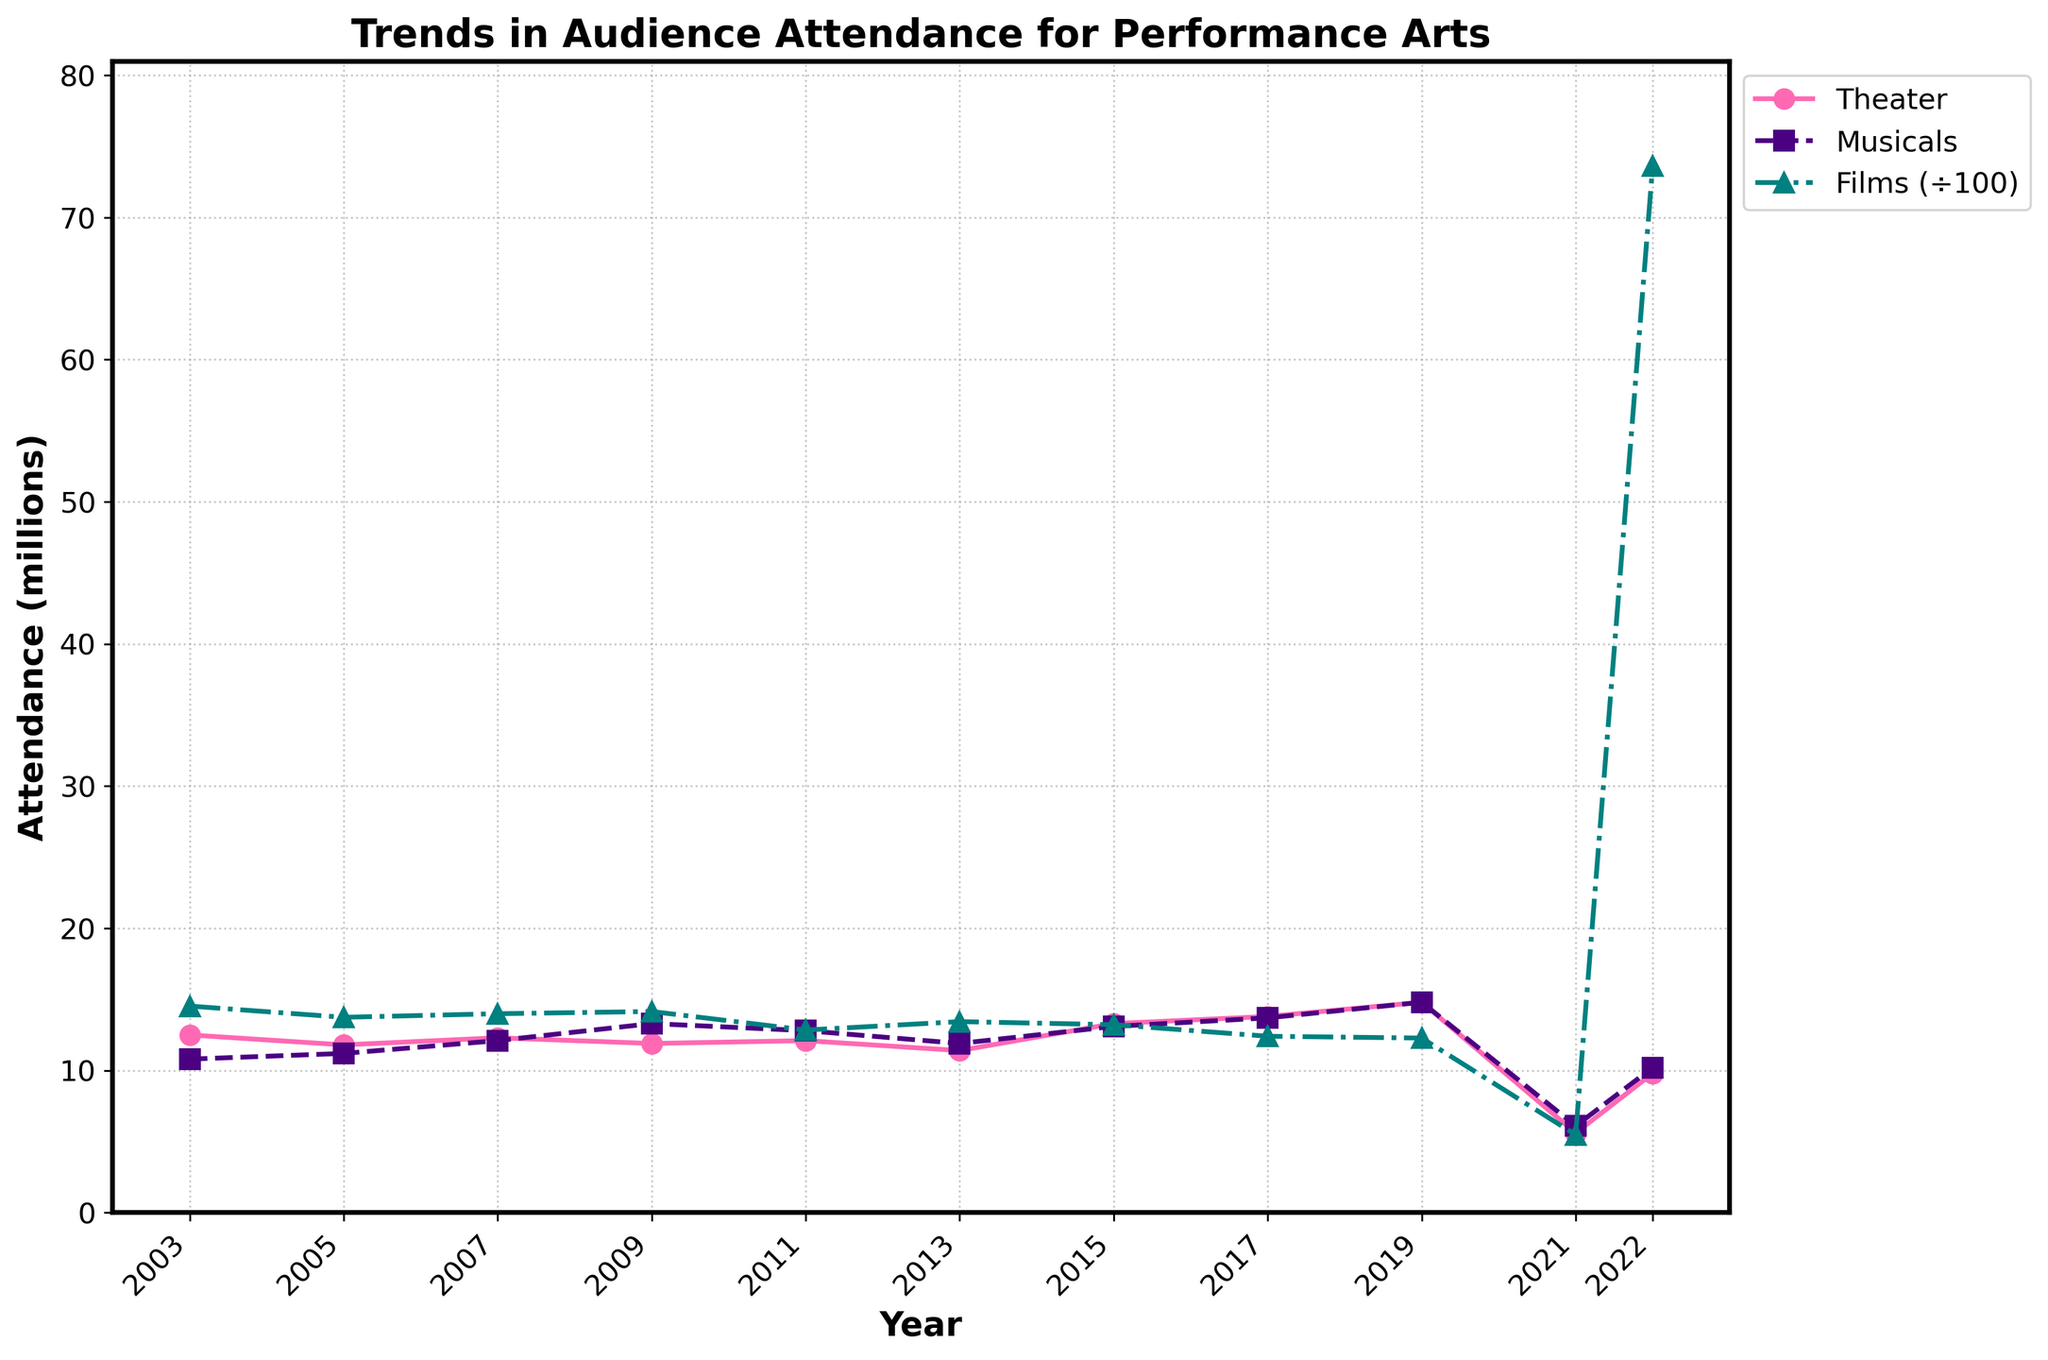What trend can be observed for theater attendance from 2003 to 2022? Theater attendance shows some fluctuations but generally an increasing trend, peaking in 2019 and then dropping significantly in 2021 before partially recovering in 2022.
Answer: Generally increasing with fluctuations What's the attendance for musicals in 2017? The attendance for musicals in 2017 can be found by looking at the point on the musicals line corresponding to 2017.
Answer: 13.7 million What is the largest percentage decrease observed in film attendance between any two consecutive years? The percentage decrease can be calculated between all consecutive years, the largest drop is from 2019 to 2021. The decrease is ((1228.1 - 548.2) / 1228.1) * 100 = 55.35%.
Answer: 55.35% Which year shows the lowest attendance for theater and what could be a possible explanation? The lowest attendance for theater is in 2021. This is likely due to the impacts of the COVID-19 pandemic.
Answer: 2021 due to the COVID-19 pandemic On average, how does musical attendance in 2022 compare to the average musical attendance from 2003 to 2019? First, calculate the average musical attendance from 2003 to 2019 ((10.8+11.2+12.1+13.3+12.8+11.9+13.1+13.7+14.8)/9 = 12.39). Compare with 10.2 in 2022.
Answer: It is lower; 10.2 compared to 12.39 How did film attendance change from 2021 to 2022? Look at the film attendance values for 2021 and 2022, which are 548.2 and 7362.1 respectively. The change is a significant increase.
Answer: Increased significantly Which performance art had the most consistent attendance over the years? By looking at all three lines, theater and musicals show more consistent fluctuations compared to the dramatic drop and spike in film attendance.
Answer: Theater and musicals What was the highest attendance recorded for musicals and in which year did it occur? The highest attendance for musicals appears in 2019, where the value reaches 14.8.
Answer: 2019 In 2022, how does the film attendance compare when scaled down to match the scale of other performance arts? Film attendance in 2022 is 7362.1, scaled down by dividing by 100 gives 73.62, which is much higher than the others.
Answer: Much higher Looking at all years, which genre had the least fluctuation in attendance and what can you infer? Theater and musicals have less fluctuation compared to films. Theater and musicals generally show minor yearly changes while film has significant swings.
Answer: Theater and musicals have minor changes, films fluctuate heavily 